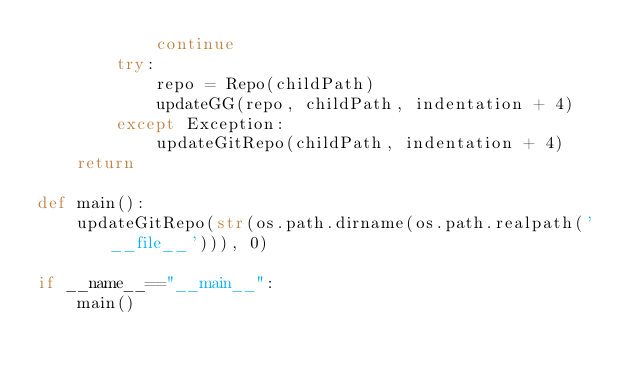Convert code to text. <code><loc_0><loc_0><loc_500><loc_500><_Python_>            continue
        try:
            repo = Repo(childPath)
            updateGG(repo, childPath, indentation + 4)
        except Exception:
            updateGitRepo(childPath, indentation + 4)
    return

def main():
    updateGitRepo(str(os.path.dirname(os.path.realpath('__file__'))), 0)

if __name__=="__main__":
    main()</code> 